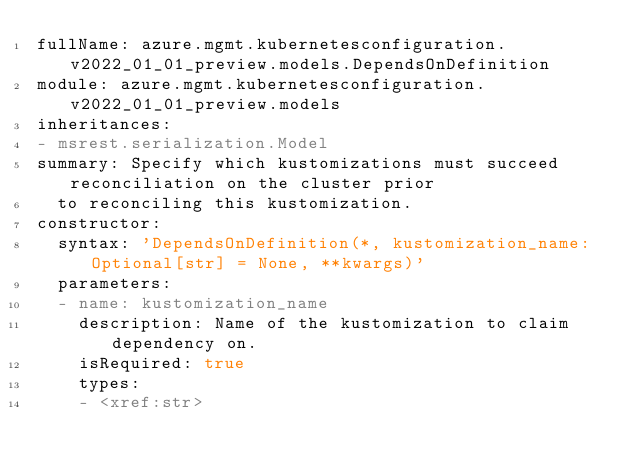Convert code to text. <code><loc_0><loc_0><loc_500><loc_500><_YAML_>fullName: azure.mgmt.kubernetesconfiguration.v2022_01_01_preview.models.DependsOnDefinition
module: azure.mgmt.kubernetesconfiguration.v2022_01_01_preview.models
inheritances:
- msrest.serialization.Model
summary: Specify which kustomizations must succeed reconciliation on the cluster prior
  to reconciling this kustomization.
constructor:
  syntax: 'DependsOnDefinition(*, kustomization_name: Optional[str] = None, **kwargs)'
  parameters:
  - name: kustomization_name
    description: Name of the kustomization to claim dependency on.
    isRequired: true
    types:
    - <xref:str>
</code> 